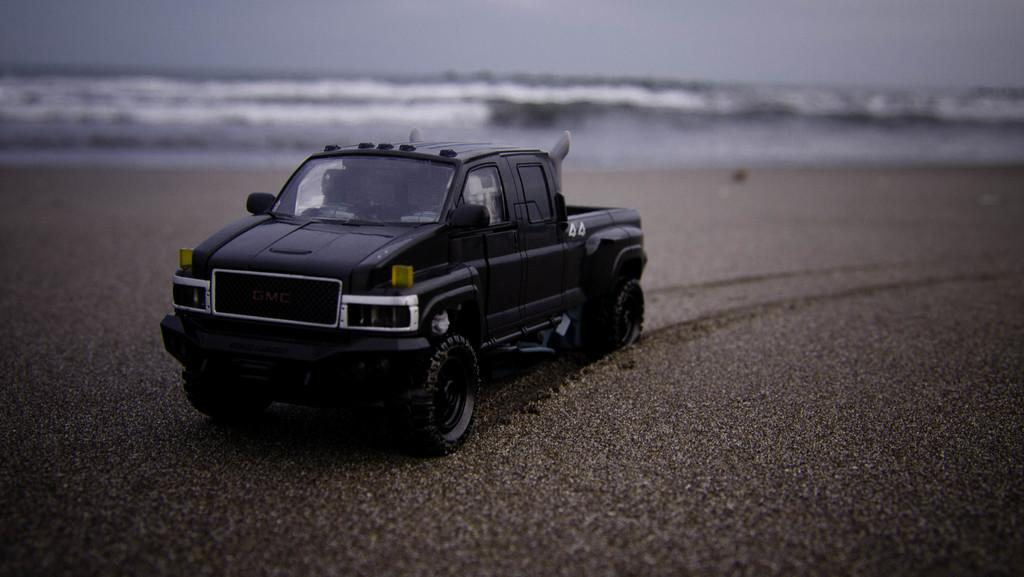What color is the vehicle in the image? The vehicle in the image is black. Where is the vehicle located? The vehicle is on the beach. What can be seen in the background of the image? There is an ocean in the background of the image. What is visible at the top of the image? The sky is visible at the top of the image. What type of creature can be seen interacting with the vehicle on the beach? There is no creature interacting with the vehicle in the image. How many grains of sand are visible on the beach in the image? It is not possible to count the exact number of grains of sand in the image, as there are too many to accurately quantify. 